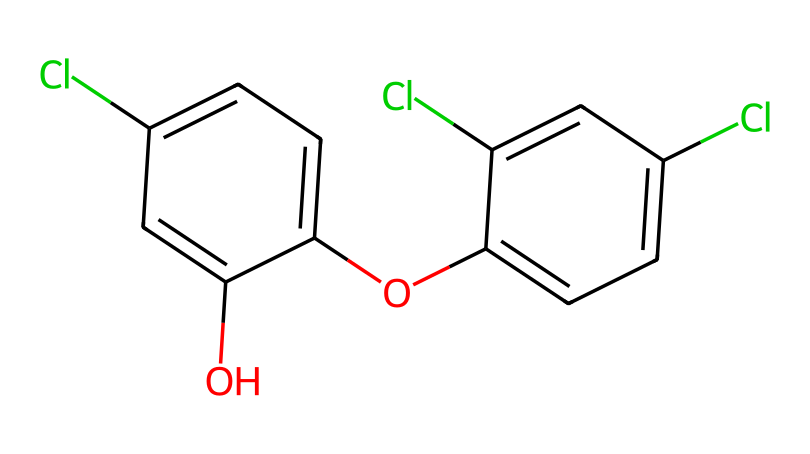What is the molecular formula of triclosan? To determine the molecular formula, we count each type of atom from the SMILES representation. The structure has: 2 Chlorine (Cl) atoms, 12 Carbon (C) atoms, 8 Hydrogen (H) atoms, and 2 Oxygen (O) atoms. Thus, the molecular formula is C12H8Cl3O2.
Answer: C12H8Cl3O2 How many aromatic rings are present in this chemical? By examining the SMILES representation, we can identify that there are two distinct cyclic structures formed by alternating single and double bonds, indicating the presence of two aromatic rings.
Answer: 2 What is the function of triclosan in antibacterial soaps? Triclosan serves as an antibacterial agent, which helps to kill or inhibit the growth of bacteria, contributing to the effectiveness of the soap in reducing bacterial presence on the skin.
Answer: antibacterial agent How many chlorine atoms are in triclosan? From the SMILES notation, we can count that there are three chlorine atoms (indicated by Cl twice), confirming their presence in the molecular structure.
Answer: 3 What type of chemical compound does triclosan belong to? Analyzing the structure and its functional groups, triclosan is classified as a phenol due to the presence of hydroxyl (OH) group attached to a benzene ring, and it's also a biocide due to its antimicrobial properties.
Answer: phenol What is the significance of the hydroxyl group in triclosan? The hydroxyl group (OH) in the structure is crucial as it contributes to the solubility of the compound in water and enhances its antibacterial properties by allowing interactions with microbial cell membranes.
Answer: increases solubility and antibacterial properties 